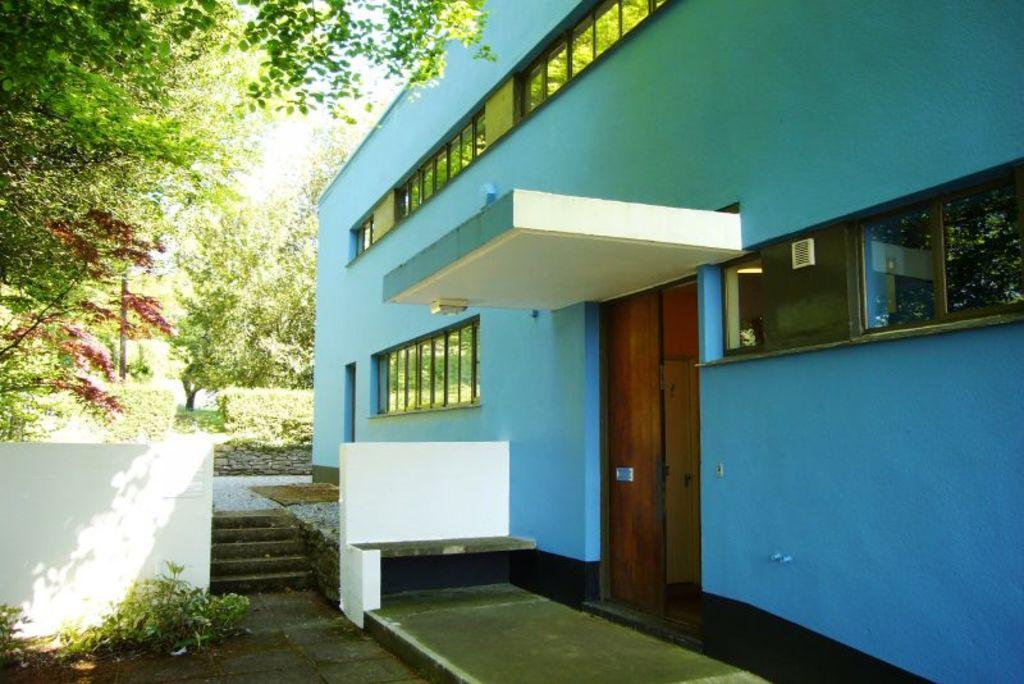What type of structure is visible in the image? There is a building in the image. What features can be seen on the building? The building has windows, doors, stairs, and a wall. What is visible in the background of the image? There are trees in the background of the image. How does the building exhibit an impulse to sleep in the image? The building does not exhibit an impulse to sleep in the image, as it is an inanimate object and cannot experience emotions or impulses. 